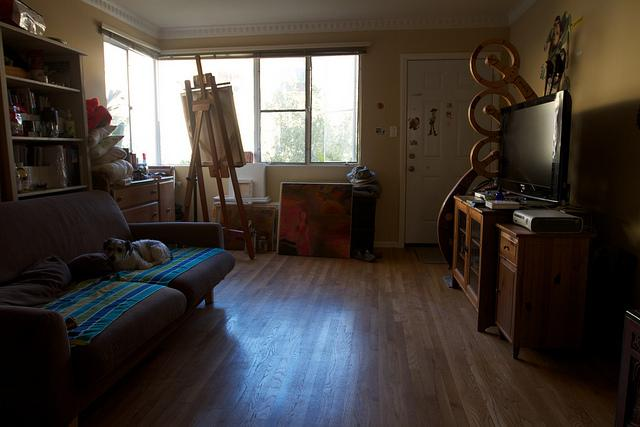What is likely on the item by the window? Please explain your reasoning. painting. When people paint, they use an easel to hold up their canvas. 